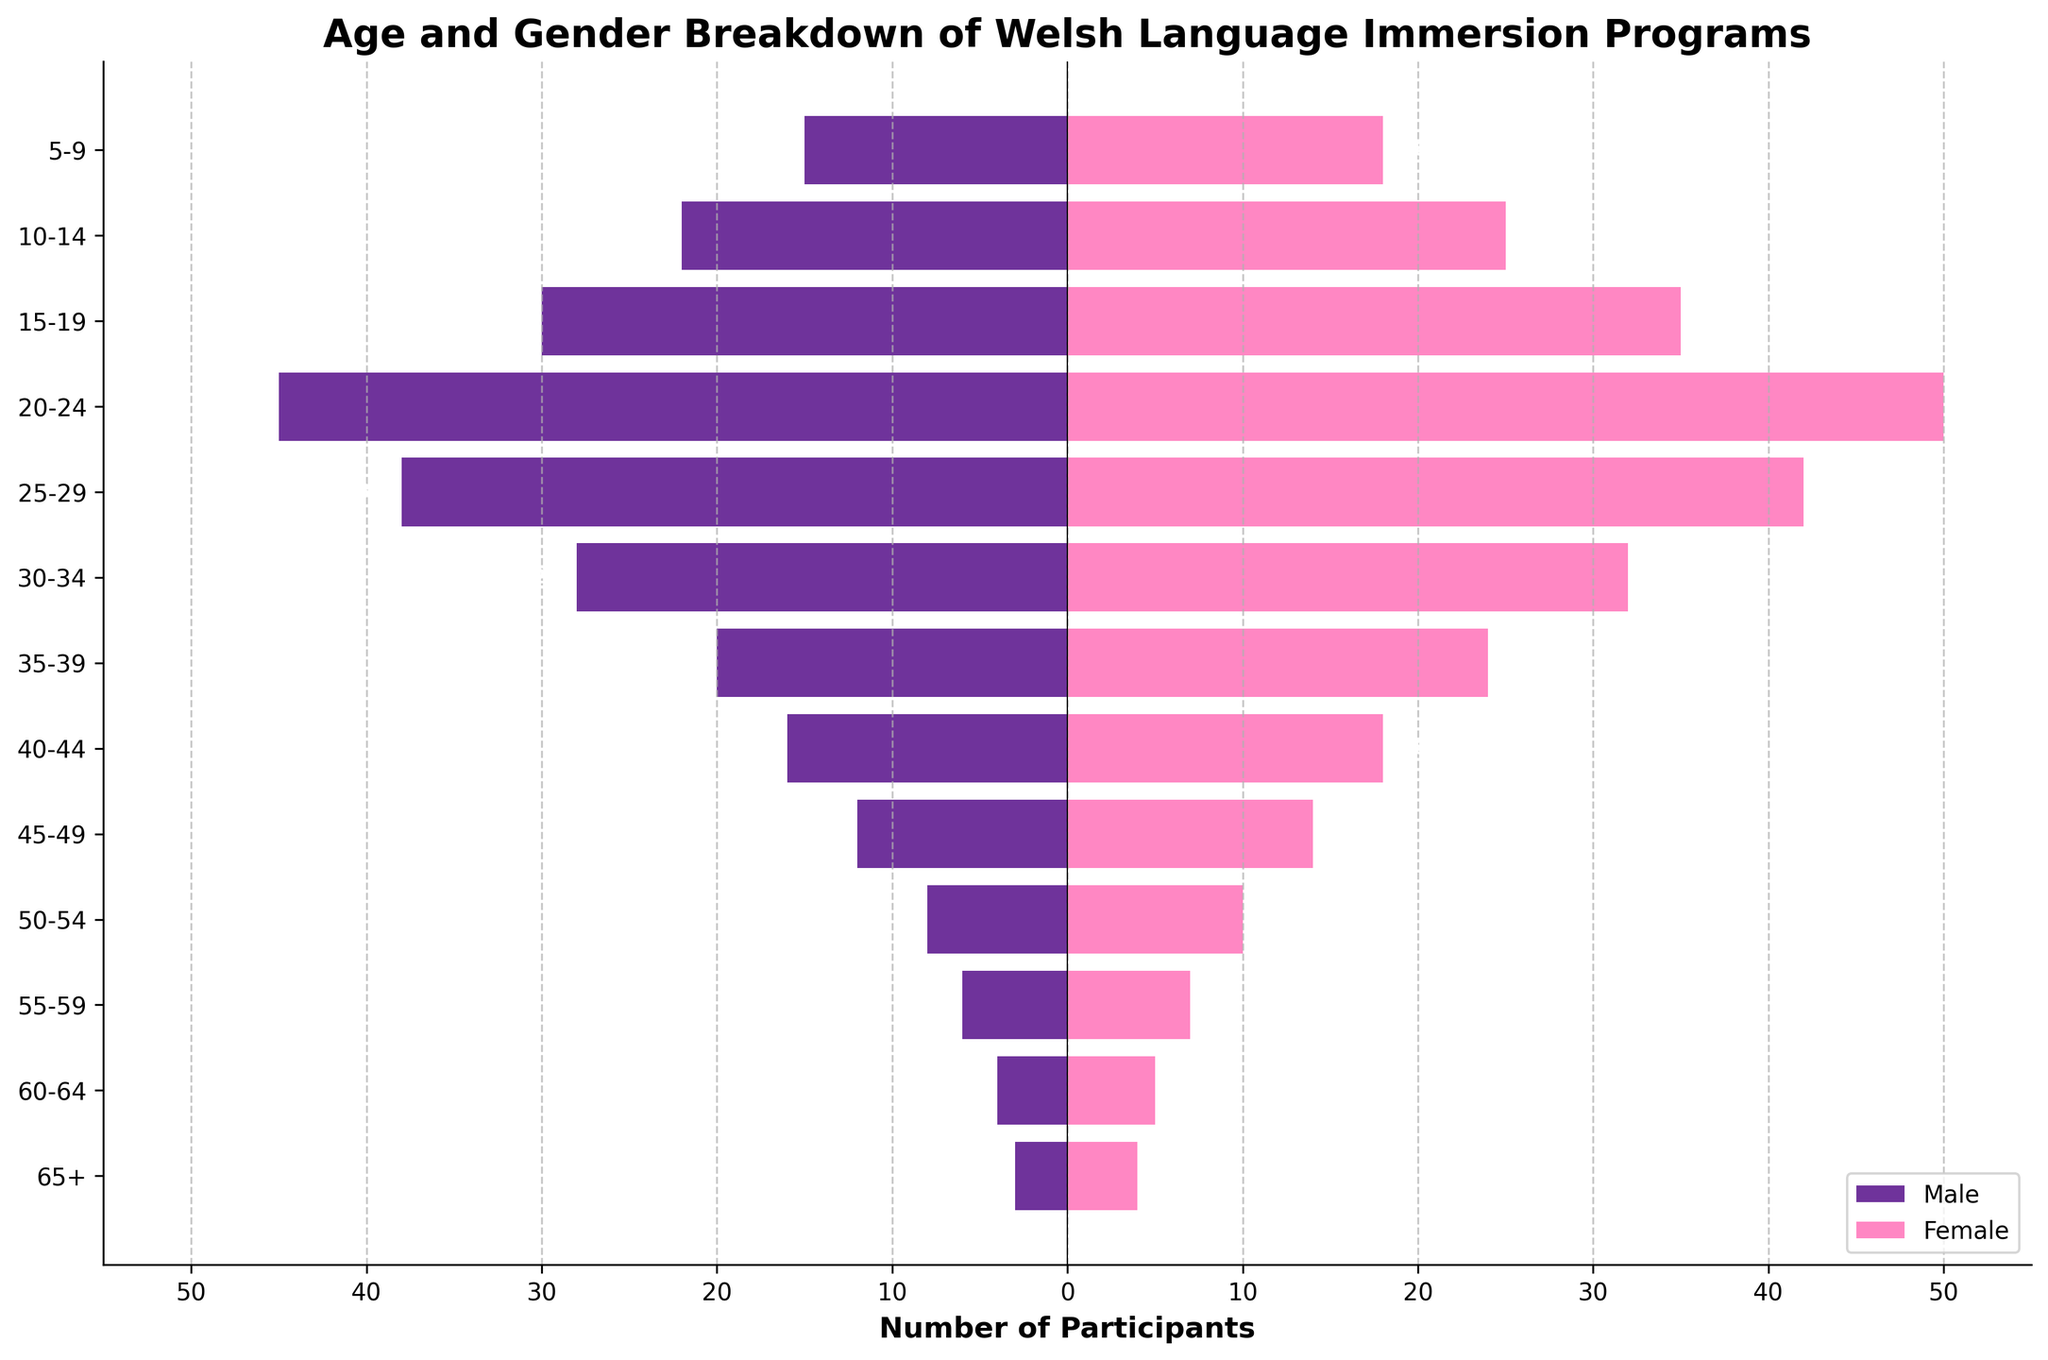What is the age group with the highest number of female participants? By looking at the length of the bars on the right side of the chart (which represents female participants), we can see that the "20-24" age group has the longest bar, indicating the highest number of female participants.
Answer: 20-24 Which age group has more male participants, 30-34 or 40-44? By comparing the lengths of the bars on the left side of the chart for age groups "30-34" and "40-44", we see that the bar for "30-34" is longer, indicating more male participants in the 30-34 age group.
Answer: 30-34 What is the combined total of participants for the age group 5-9? Add the number of male and female participants in the 5-9 age group. Male participants are 15, and female participants are 18. So, the total is 15 + 18.
Answer: 33 How many more female participants are there in the 25-29 age group compared to the 55-59 age group? First, find the number of female participants in the 25-29 age group (42) and in the 55-59 age group (7). Then, subtract the number of female participants in the 55-59 age group from the 25-29 age group: 42 - 7.
Answer: 35 What percentage of the total participants in the 60-64 age group are male? First, calculate the total participants in the 60-64 age group: 4 (male) + 5 (female) = 9. Then, find the male percentage: (4/9) * 100%.
Answer: 44.44% How has the number of participants in the "65+" age group divided by gender? Look at the bars for the "65+" age group. There are 3 male participants and 4 female participants.
Answer: 3 males, 4 females Are there any age groups where the number of male participants is equal to the number of female participants? Check the bars for each age group to see if any have bars of equal length on both sides of the axis. No age groups have equal male and female participants.
Answer: No What can be said about the gender distribution in the 15-19 to the 25-29 age groups? Observing these age groups, we notice that the number of female participants is consistently higher than that of male participants in each age group.
Answer: Female participants are higher in each age group 